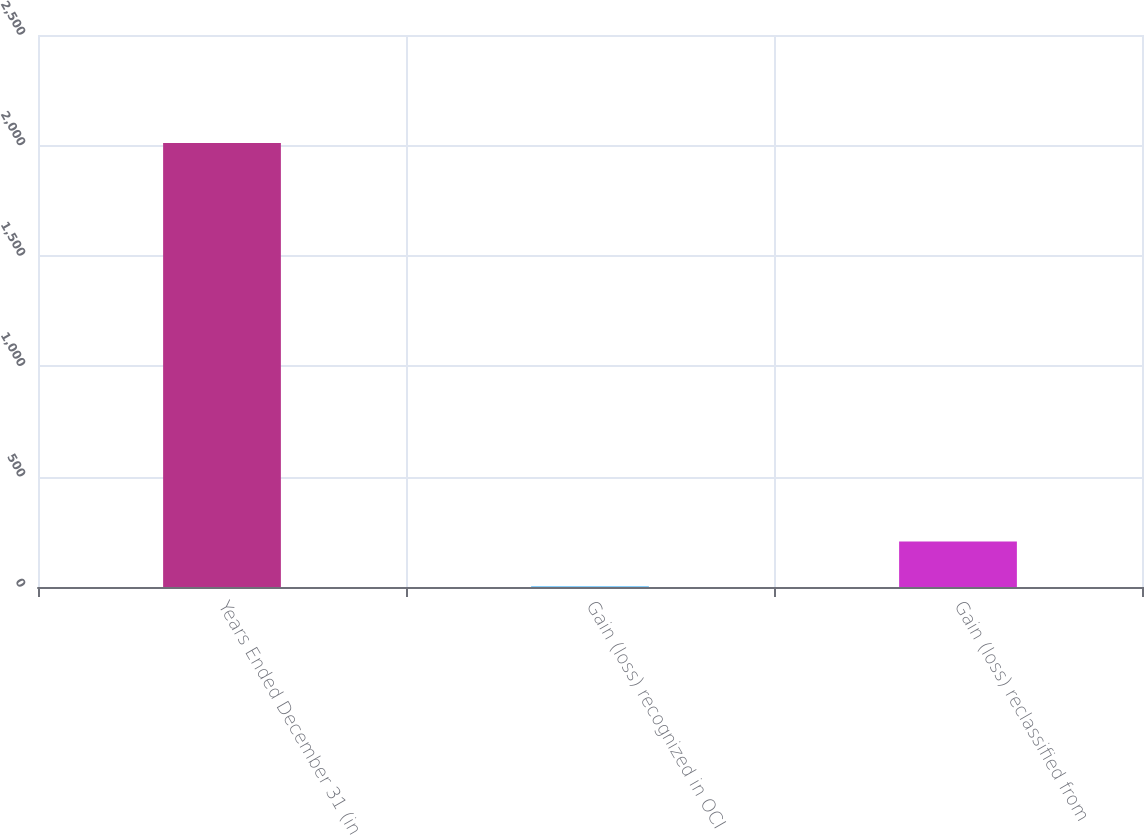Convert chart to OTSL. <chart><loc_0><loc_0><loc_500><loc_500><bar_chart><fcel>Years Ended December 31 (in<fcel>Gain (loss) recognized in OCI<fcel>Gain (loss) reclassified from<nl><fcel>2011<fcel>5<fcel>205.6<nl></chart> 